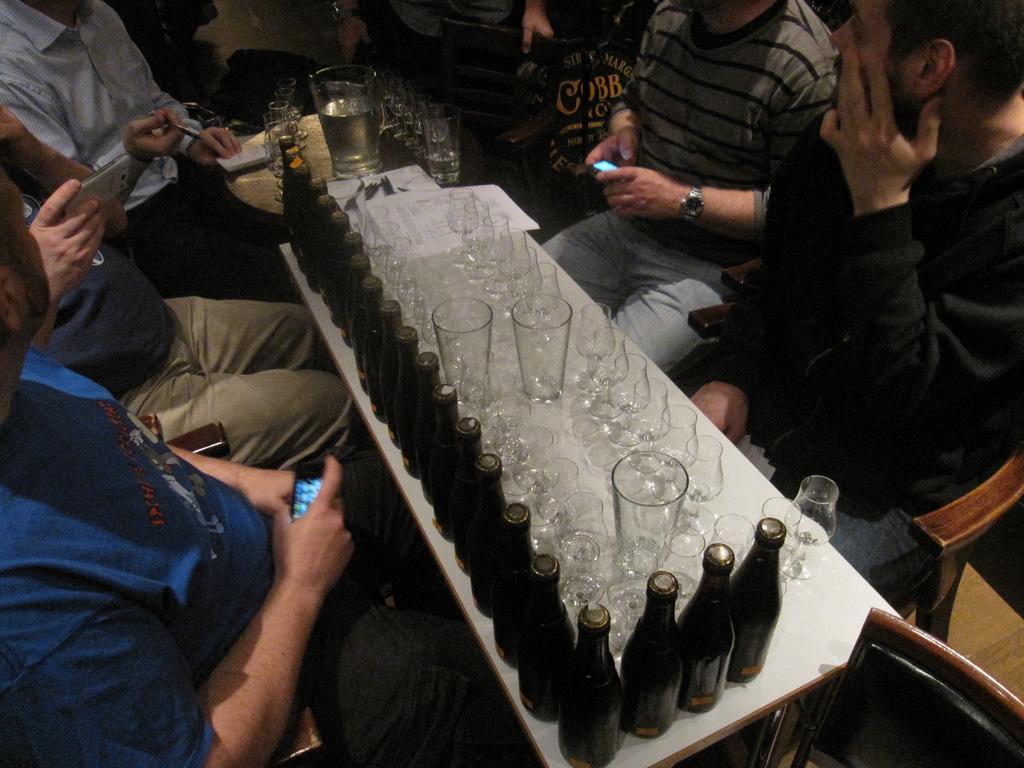Can you describe this image briefly? In the image we can see there are people sitting, they are wearing clothes and some of them are holding gadget in their hands. Here we can see bottles and glasses and wine glasses. Here we can see a table and chairs. 